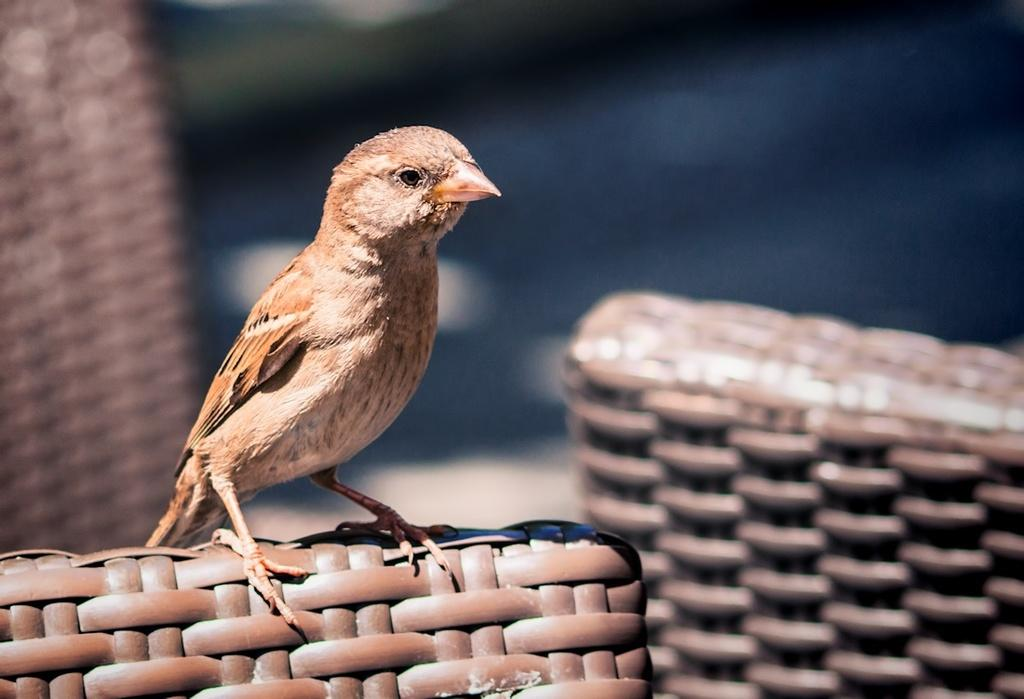What type of animal is present in the image? There is a bird in the image. What is the bird doing in the image? The bird is sitting on an object. Can you describe the background of the image? The background of the image is blurred. What unit of measurement is the bird using to achieve its goals in the image? There is no indication in the image that the bird is using any unit of measurement or has any goals. 